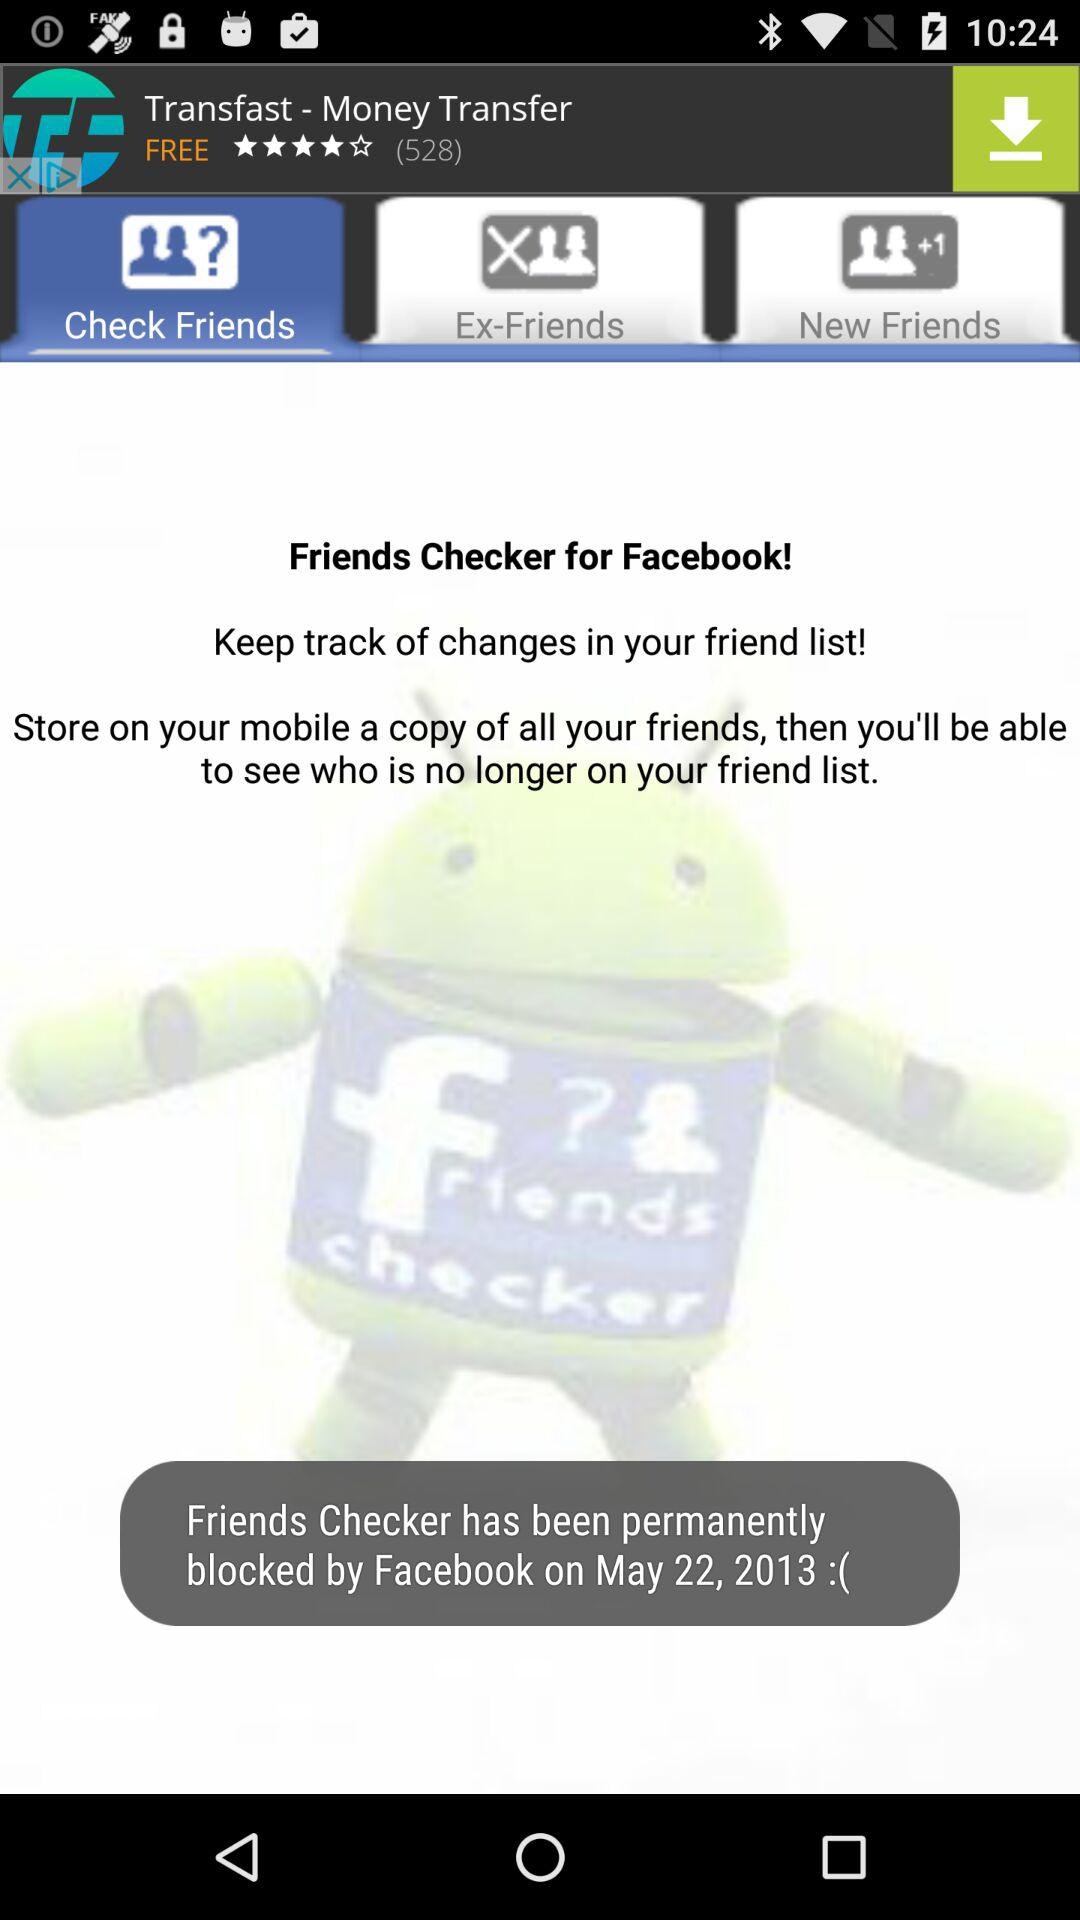What is the name of the application? The name of the application is "Friends Checker". 